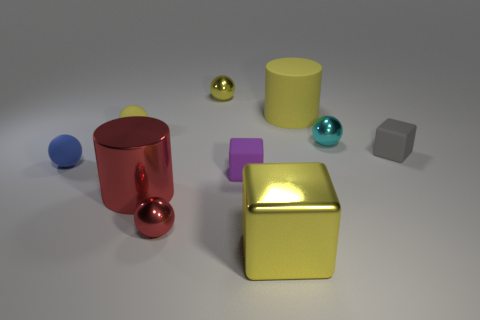Do the small sphere right of the big rubber thing and the yellow cylinder have the same material?
Make the answer very short. No. Are the big yellow block and the gray object made of the same material?
Provide a succinct answer. No. Are the blue thing and the yellow ball that is right of the tiny red metal object made of the same material?
Your answer should be very brief. No. Is there a big object that is on the right side of the cube on the left side of the metallic block?
Keep it short and to the point. Yes. There is a small cyan thing that is the same shape as the tiny red thing; what is it made of?
Ensure brevity in your answer.  Metal. There is a tiny rubber sphere to the right of the blue object; how many yellow shiny objects are in front of it?
Give a very brief answer. 1. How many things are large purple matte objects or big cylinders in front of the blue rubber object?
Offer a very short reply. 1. The big cylinder in front of the sphere left of the tiny rubber sphere behind the tiny gray matte thing is made of what material?
Provide a succinct answer. Metal. What is the size of the cylinder that is the same material as the gray block?
Give a very brief answer. Large. What color is the cylinder to the right of the small yellow object on the right side of the red cylinder?
Provide a short and direct response. Yellow. 